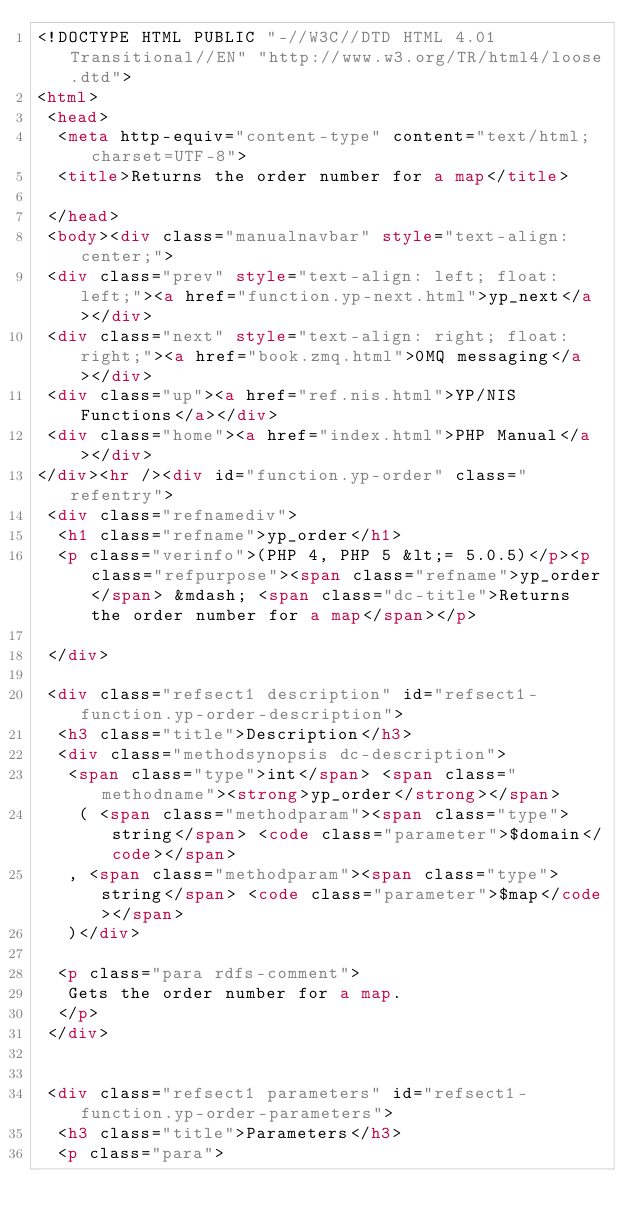<code> <loc_0><loc_0><loc_500><loc_500><_HTML_><!DOCTYPE HTML PUBLIC "-//W3C//DTD HTML 4.01 Transitional//EN" "http://www.w3.org/TR/html4/loose.dtd">
<html>
 <head>
  <meta http-equiv="content-type" content="text/html; charset=UTF-8">
  <title>Returns the order number for a map</title>

 </head>
 <body><div class="manualnavbar" style="text-align: center;">
 <div class="prev" style="text-align: left; float: left;"><a href="function.yp-next.html">yp_next</a></div>
 <div class="next" style="text-align: right; float: right;"><a href="book.zmq.html">0MQ messaging</a></div>
 <div class="up"><a href="ref.nis.html">YP/NIS Functions</a></div>
 <div class="home"><a href="index.html">PHP Manual</a></div>
</div><hr /><div id="function.yp-order" class="refentry">
 <div class="refnamediv">
  <h1 class="refname">yp_order</h1>
  <p class="verinfo">(PHP 4, PHP 5 &lt;= 5.0.5)</p><p class="refpurpose"><span class="refname">yp_order</span> &mdash; <span class="dc-title">Returns the order number for a map</span></p>

 </div>
 
 <div class="refsect1 description" id="refsect1-function.yp-order-description">
  <h3 class="title">Description</h3>
  <div class="methodsynopsis dc-description">
   <span class="type">int</span> <span class="methodname"><strong>yp_order</strong></span>
    ( <span class="methodparam"><span class="type">string</span> <code class="parameter">$domain</code></span>
   , <span class="methodparam"><span class="type">string</span> <code class="parameter">$map</code></span>
   )</div>

  <p class="para rdfs-comment">
   Gets the order number for a map.
  </p>
 </div>


 <div class="refsect1 parameters" id="refsect1-function.yp-order-parameters">
  <h3 class="title">Parameters</h3>
  <p class="para"></code> 